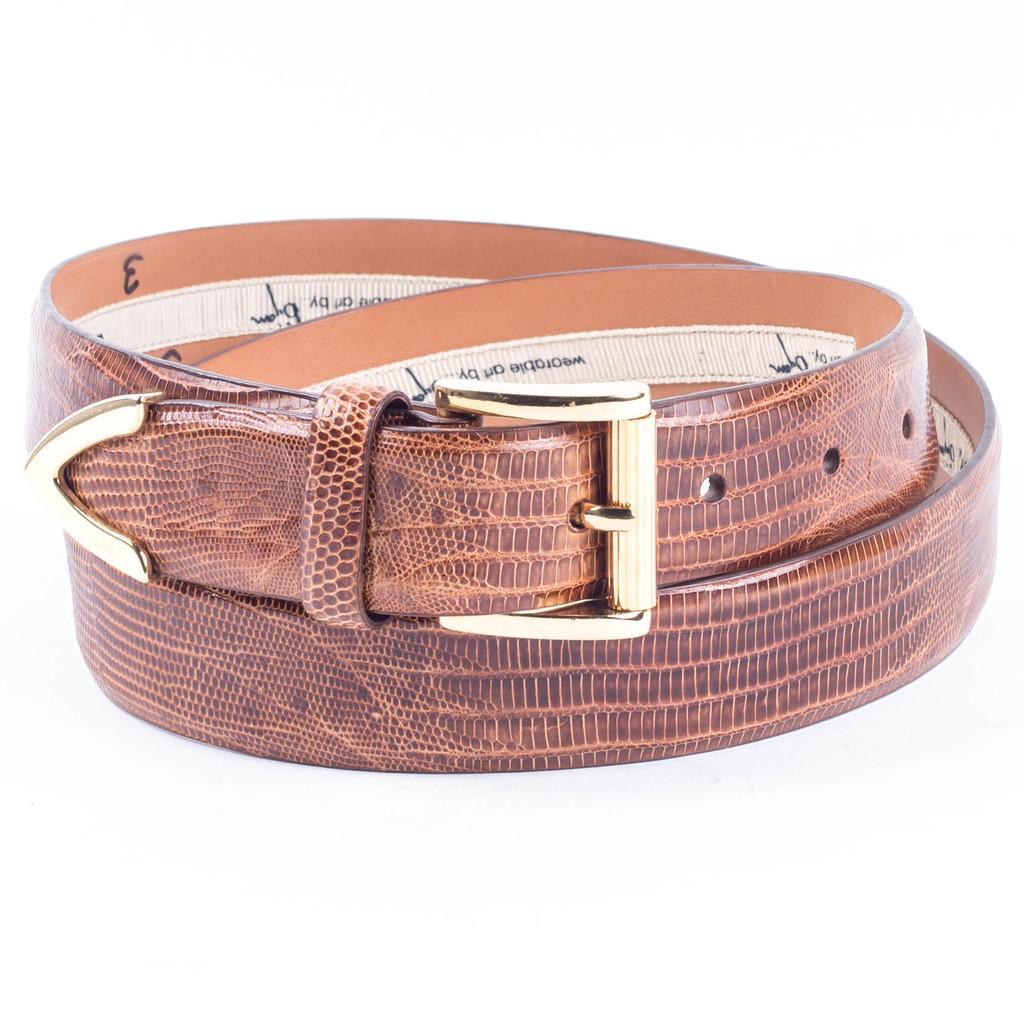Could you give a brief overview of what you see in this image? This image consists of a belt in brown color is kept on a table. The background looks white in color. 